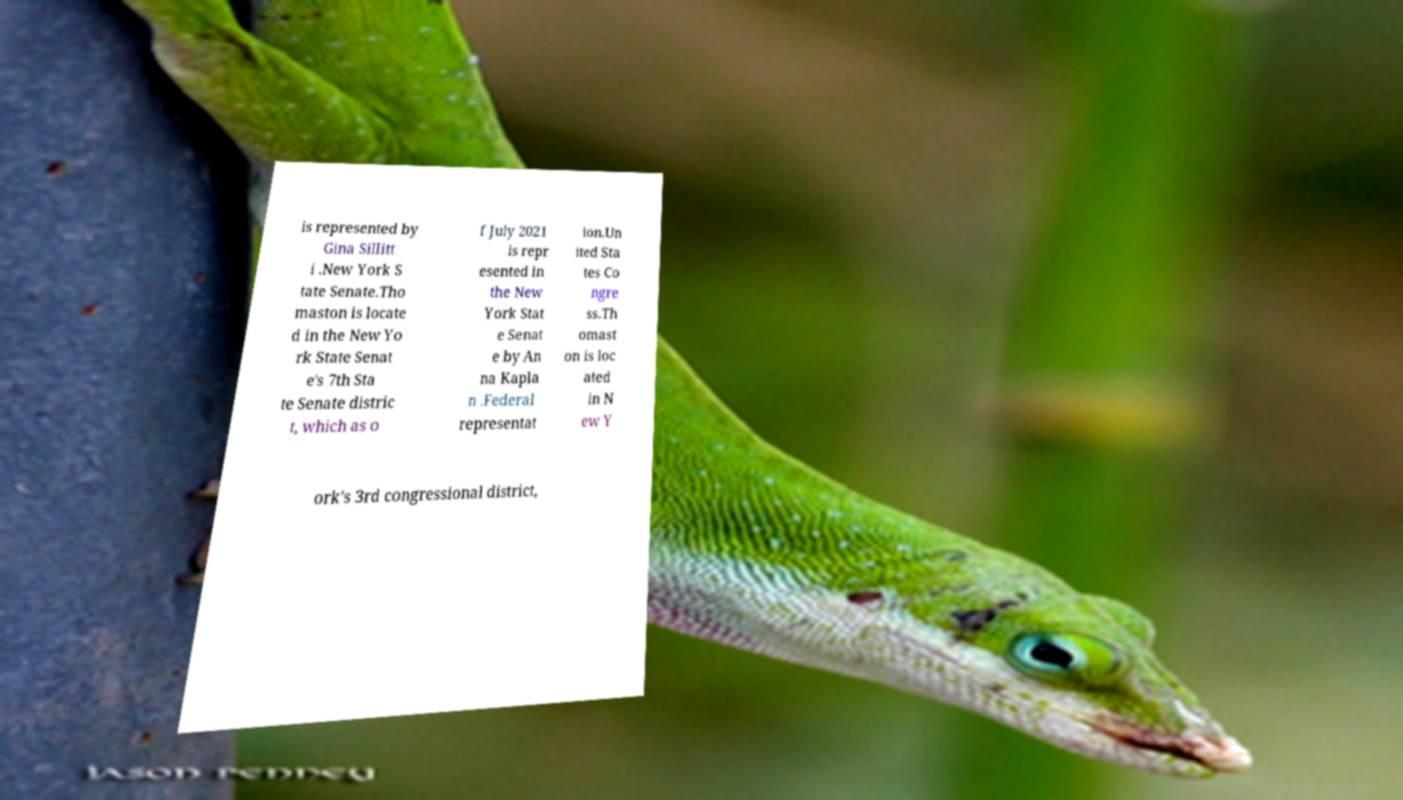What messages or text are displayed in this image? I need them in a readable, typed format. is represented by Gina Sillitt i .New York S tate Senate.Tho maston is locate d in the New Yo rk State Senat e's 7th Sta te Senate distric t, which as o f July 2021 is repr esented in the New York Stat e Senat e by An na Kapla n .Federal representat ion.Un ited Sta tes Co ngre ss.Th omast on is loc ated in N ew Y ork's 3rd congressional district, 